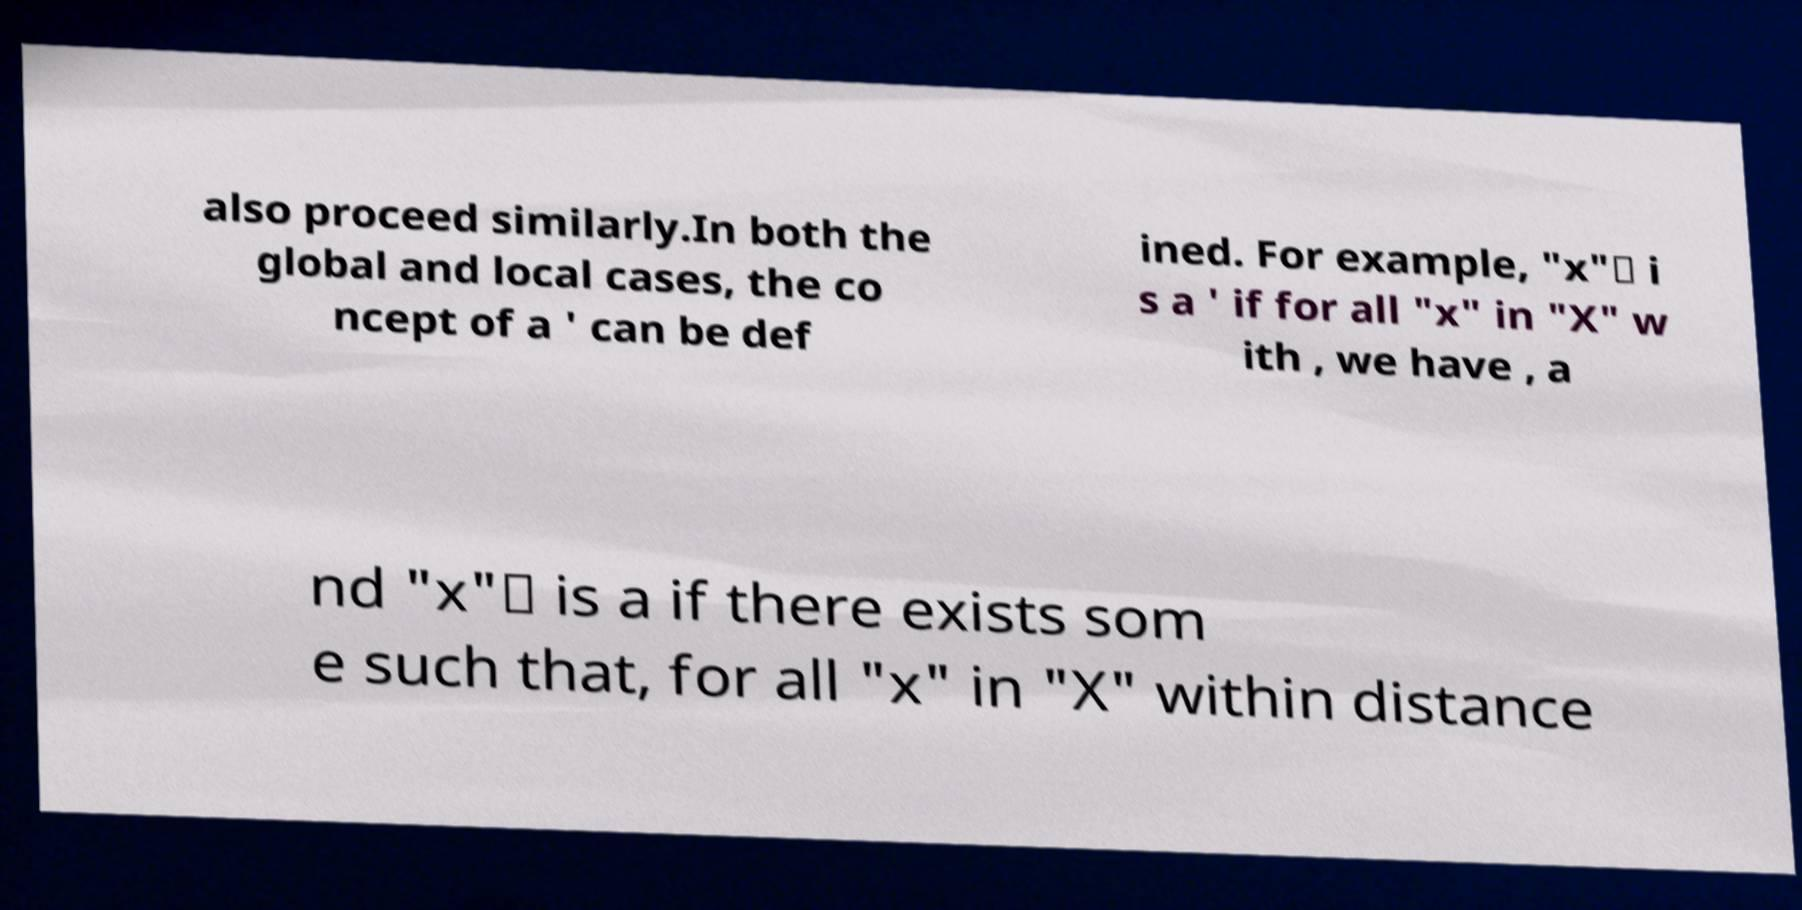Can you read and provide the text displayed in the image?This photo seems to have some interesting text. Can you extract and type it out for me? also proceed similarly.In both the global and local cases, the co ncept of a ' can be def ined. For example, "x"∗ i s a ' if for all "x" in "X" w ith , we have , a nd "x"∗ is a if there exists som e such that, for all "x" in "X" within distance 